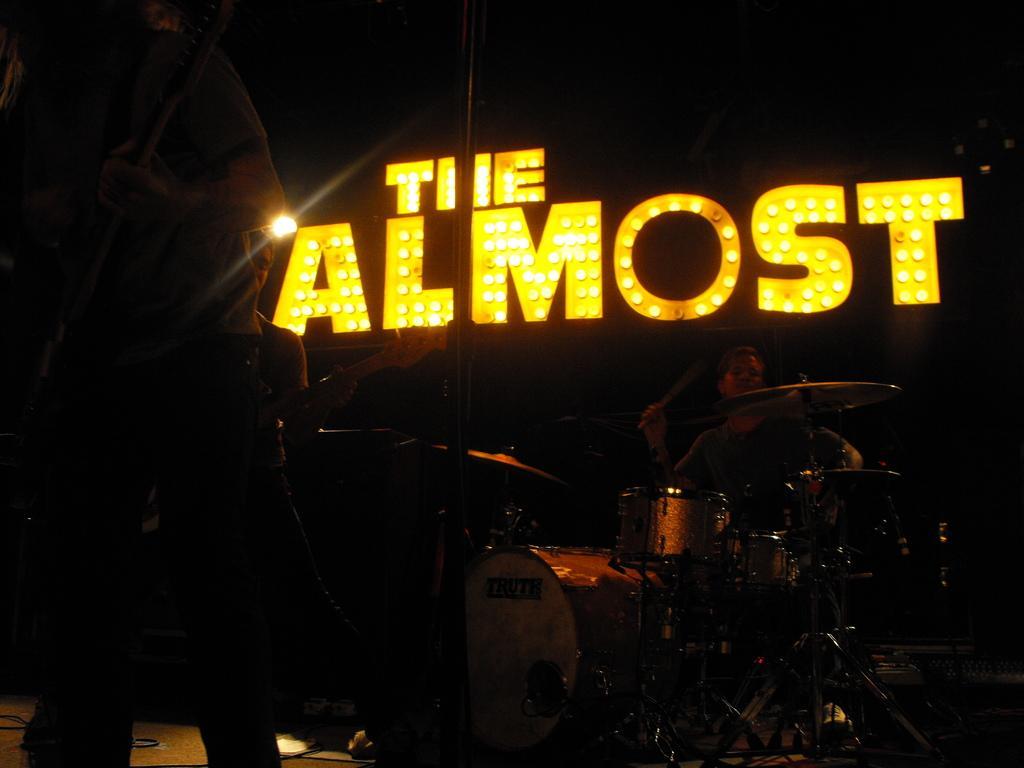Describe this image in one or two sentences. Here is a person standing and playing guitar. here is another person sitting and playing drums. this looks like a stage show. These are the lights at the background. I can see another person standing and holding musical instrument. 